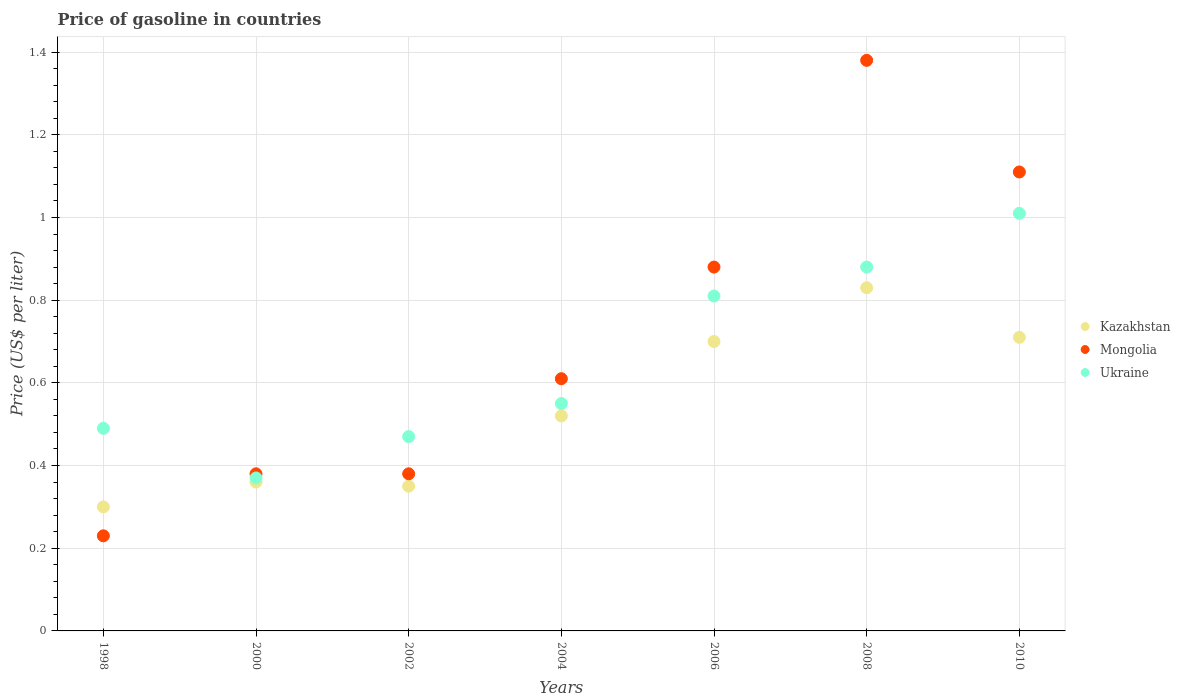What is the price of gasoline in Kazakhstan in 2000?
Give a very brief answer. 0.36. Across all years, what is the maximum price of gasoline in Kazakhstan?
Your response must be concise. 0.83. Across all years, what is the minimum price of gasoline in Ukraine?
Keep it short and to the point. 0.37. What is the total price of gasoline in Kazakhstan in the graph?
Your response must be concise. 3.77. What is the difference between the price of gasoline in Ukraine in 2000 and that in 2006?
Your response must be concise. -0.44. What is the difference between the price of gasoline in Kazakhstan in 2002 and the price of gasoline in Ukraine in 2008?
Make the answer very short. -0.53. What is the average price of gasoline in Kazakhstan per year?
Make the answer very short. 0.54. In the year 2006, what is the difference between the price of gasoline in Ukraine and price of gasoline in Kazakhstan?
Provide a succinct answer. 0.11. In how many years, is the price of gasoline in Ukraine greater than 1.12 US$?
Provide a succinct answer. 0. What is the ratio of the price of gasoline in Mongolia in 1998 to that in 2008?
Keep it short and to the point. 0.17. Is the difference between the price of gasoline in Ukraine in 2006 and 2008 greater than the difference between the price of gasoline in Kazakhstan in 2006 and 2008?
Provide a short and direct response. Yes. What is the difference between the highest and the second highest price of gasoline in Kazakhstan?
Provide a short and direct response. 0.12. What is the difference between the highest and the lowest price of gasoline in Mongolia?
Provide a short and direct response. 1.15. Is the sum of the price of gasoline in Mongolia in 1998 and 2000 greater than the maximum price of gasoline in Kazakhstan across all years?
Your answer should be compact. No. Does the price of gasoline in Ukraine monotonically increase over the years?
Offer a terse response. No. How many dotlines are there?
Offer a very short reply. 3. How many years are there in the graph?
Ensure brevity in your answer.  7. What is the difference between two consecutive major ticks on the Y-axis?
Provide a short and direct response. 0.2. Are the values on the major ticks of Y-axis written in scientific E-notation?
Provide a short and direct response. No. Does the graph contain any zero values?
Keep it short and to the point. No. Does the graph contain grids?
Offer a very short reply. Yes. Where does the legend appear in the graph?
Offer a terse response. Center right. How are the legend labels stacked?
Provide a short and direct response. Vertical. What is the title of the graph?
Your response must be concise. Price of gasoline in countries. What is the label or title of the Y-axis?
Your response must be concise. Price (US$ per liter). What is the Price (US$ per liter) of Mongolia in 1998?
Keep it short and to the point. 0.23. What is the Price (US$ per liter) in Ukraine in 1998?
Offer a terse response. 0.49. What is the Price (US$ per liter) in Kazakhstan in 2000?
Offer a very short reply. 0.36. What is the Price (US$ per liter) in Mongolia in 2000?
Keep it short and to the point. 0.38. What is the Price (US$ per liter) in Ukraine in 2000?
Keep it short and to the point. 0.37. What is the Price (US$ per liter) in Mongolia in 2002?
Your answer should be very brief. 0.38. What is the Price (US$ per liter) in Ukraine in 2002?
Ensure brevity in your answer.  0.47. What is the Price (US$ per liter) in Kazakhstan in 2004?
Provide a short and direct response. 0.52. What is the Price (US$ per liter) of Mongolia in 2004?
Keep it short and to the point. 0.61. What is the Price (US$ per liter) of Ukraine in 2004?
Your answer should be very brief. 0.55. What is the Price (US$ per liter) of Ukraine in 2006?
Provide a succinct answer. 0.81. What is the Price (US$ per liter) in Kazakhstan in 2008?
Make the answer very short. 0.83. What is the Price (US$ per liter) in Mongolia in 2008?
Your answer should be compact. 1.38. What is the Price (US$ per liter) in Ukraine in 2008?
Offer a very short reply. 0.88. What is the Price (US$ per liter) of Kazakhstan in 2010?
Your answer should be compact. 0.71. What is the Price (US$ per liter) of Mongolia in 2010?
Give a very brief answer. 1.11. Across all years, what is the maximum Price (US$ per liter) of Kazakhstan?
Give a very brief answer. 0.83. Across all years, what is the maximum Price (US$ per liter) in Mongolia?
Your answer should be very brief. 1.38. Across all years, what is the maximum Price (US$ per liter) in Ukraine?
Provide a succinct answer. 1.01. Across all years, what is the minimum Price (US$ per liter) in Kazakhstan?
Your answer should be very brief. 0.3. Across all years, what is the minimum Price (US$ per liter) of Mongolia?
Give a very brief answer. 0.23. Across all years, what is the minimum Price (US$ per liter) of Ukraine?
Make the answer very short. 0.37. What is the total Price (US$ per liter) in Kazakhstan in the graph?
Offer a very short reply. 3.77. What is the total Price (US$ per liter) in Mongolia in the graph?
Your response must be concise. 4.97. What is the total Price (US$ per liter) in Ukraine in the graph?
Provide a short and direct response. 4.58. What is the difference between the Price (US$ per liter) of Kazakhstan in 1998 and that in 2000?
Keep it short and to the point. -0.06. What is the difference between the Price (US$ per liter) of Ukraine in 1998 and that in 2000?
Provide a succinct answer. 0.12. What is the difference between the Price (US$ per liter) of Kazakhstan in 1998 and that in 2004?
Offer a very short reply. -0.22. What is the difference between the Price (US$ per liter) of Mongolia in 1998 and that in 2004?
Give a very brief answer. -0.38. What is the difference between the Price (US$ per liter) in Ukraine in 1998 and that in 2004?
Your response must be concise. -0.06. What is the difference between the Price (US$ per liter) of Kazakhstan in 1998 and that in 2006?
Give a very brief answer. -0.4. What is the difference between the Price (US$ per liter) in Mongolia in 1998 and that in 2006?
Make the answer very short. -0.65. What is the difference between the Price (US$ per liter) of Ukraine in 1998 and that in 2006?
Keep it short and to the point. -0.32. What is the difference between the Price (US$ per liter) in Kazakhstan in 1998 and that in 2008?
Make the answer very short. -0.53. What is the difference between the Price (US$ per liter) of Mongolia in 1998 and that in 2008?
Your answer should be compact. -1.15. What is the difference between the Price (US$ per liter) in Ukraine in 1998 and that in 2008?
Make the answer very short. -0.39. What is the difference between the Price (US$ per liter) in Kazakhstan in 1998 and that in 2010?
Offer a terse response. -0.41. What is the difference between the Price (US$ per liter) in Mongolia in 1998 and that in 2010?
Keep it short and to the point. -0.88. What is the difference between the Price (US$ per liter) in Ukraine in 1998 and that in 2010?
Your answer should be compact. -0.52. What is the difference between the Price (US$ per liter) in Kazakhstan in 2000 and that in 2002?
Offer a terse response. 0.01. What is the difference between the Price (US$ per liter) of Ukraine in 2000 and that in 2002?
Your response must be concise. -0.1. What is the difference between the Price (US$ per liter) in Kazakhstan in 2000 and that in 2004?
Offer a terse response. -0.16. What is the difference between the Price (US$ per liter) of Mongolia in 2000 and that in 2004?
Your answer should be very brief. -0.23. What is the difference between the Price (US$ per liter) in Ukraine in 2000 and that in 2004?
Your answer should be very brief. -0.18. What is the difference between the Price (US$ per liter) of Kazakhstan in 2000 and that in 2006?
Offer a terse response. -0.34. What is the difference between the Price (US$ per liter) in Mongolia in 2000 and that in 2006?
Offer a very short reply. -0.5. What is the difference between the Price (US$ per liter) of Ukraine in 2000 and that in 2006?
Your answer should be compact. -0.44. What is the difference between the Price (US$ per liter) of Kazakhstan in 2000 and that in 2008?
Keep it short and to the point. -0.47. What is the difference between the Price (US$ per liter) of Mongolia in 2000 and that in 2008?
Your answer should be very brief. -1. What is the difference between the Price (US$ per liter) of Ukraine in 2000 and that in 2008?
Offer a terse response. -0.51. What is the difference between the Price (US$ per liter) of Kazakhstan in 2000 and that in 2010?
Give a very brief answer. -0.35. What is the difference between the Price (US$ per liter) of Mongolia in 2000 and that in 2010?
Provide a short and direct response. -0.73. What is the difference between the Price (US$ per liter) of Ukraine in 2000 and that in 2010?
Give a very brief answer. -0.64. What is the difference between the Price (US$ per liter) of Kazakhstan in 2002 and that in 2004?
Offer a very short reply. -0.17. What is the difference between the Price (US$ per liter) in Mongolia in 2002 and that in 2004?
Your answer should be compact. -0.23. What is the difference between the Price (US$ per liter) in Ukraine in 2002 and that in 2004?
Offer a terse response. -0.08. What is the difference between the Price (US$ per liter) in Kazakhstan in 2002 and that in 2006?
Make the answer very short. -0.35. What is the difference between the Price (US$ per liter) of Mongolia in 2002 and that in 2006?
Provide a succinct answer. -0.5. What is the difference between the Price (US$ per liter) in Ukraine in 2002 and that in 2006?
Your response must be concise. -0.34. What is the difference between the Price (US$ per liter) in Kazakhstan in 2002 and that in 2008?
Your response must be concise. -0.48. What is the difference between the Price (US$ per liter) in Mongolia in 2002 and that in 2008?
Your answer should be compact. -1. What is the difference between the Price (US$ per liter) in Ukraine in 2002 and that in 2008?
Keep it short and to the point. -0.41. What is the difference between the Price (US$ per liter) in Kazakhstan in 2002 and that in 2010?
Provide a succinct answer. -0.36. What is the difference between the Price (US$ per liter) of Mongolia in 2002 and that in 2010?
Your answer should be compact. -0.73. What is the difference between the Price (US$ per liter) in Ukraine in 2002 and that in 2010?
Offer a very short reply. -0.54. What is the difference between the Price (US$ per liter) of Kazakhstan in 2004 and that in 2006?
Give a very brief answer. -0.18. What is the difference between the Price (US$ per liter) of Mongolia in 2004 and that in 2006?
Provide a succinct answer. -0.27. What is the difference between the Price (US$ per liter) in Ukraine in 2004 and that in 2006?
Keep it short and to the point. -0.26. What is the difference between the Price (US$ per liter) of Kazakhstan in 2004 and that in 2008?
Give a very brief answer. -0.31. What is the difference between the Price (US$ per liter) of Mongolia in 2004 and that in 2008?
Your answer should be compact. -0.77. What is the difference between the Price (US$ per liter) in Ukraine in 2004 and that in 2008?
Offer a terse response. -0.33. What is the difference between the Price (US$ per liter) in Kazakhstan in 2004 and that in 2010?
Your answer should be compact. -0.19. What is the difference between the Price (US$ per liter) of Mongolia in 2004 and that in 2010?
Provide a short and direct response. -0.5. What is the difference between the Price (US$ per liter) in Ukraine in 2004 and that in 2010?
Provide a short and direct response. -0.46. What is the difference between the Price (US$ per liter) of Kazakhstan in 2006 and that in 2008?
Give a very brief answer. -0.13. What is the difference between the Price (US$ per liter) in Mongolia in 2006 and that in 2008?
Your answer should be compact. -0.5. What is the difference between the Price (US$ per liter) in Ukraine in 2006 and that in 2008?
Offer a terse response. -0.07. What is the difference between the Price (US$ per liter) of Kazakhstan in 2006 and that in 2010?
Keep it short and to the point. -0.01. What is the difference between the Price (US$ per liter) of Mongolia in 2006 and that in 2010?
Provide a succinct answer. -0.23. What is the difference between the Price (US$ per liter) of Ukraine in 2006 and that in 2010?
Keep it short and to the point. -0.2. What is the difference between the Price (US$ per liter) of Kazakhstan in 2008 and that in 2010?
Your answer should be compact. 0.12. What is the difference between the Price (US$ per liter) of Mongolia in 2008 and that in 2010?
Your answer should be compact. 0.27. What is the difference between the Price (US$ per liter) of Ukraine in 2008 and that in 2010?
Make the answer very short. -0.13. What is the difference between the Price (US$ per liter) in Kazakhstan in 1998 and the Price (US$ per liter) in Mongolia in 2000?
Your answer should be compact. -0.08. What is the difference between the Price (US$ per liter) of Kazakhstan in 1998 and the Price (US$ per liter) of Ukraine in 2000?
Offer a terse response. -0.07. What is the difference between the Price (US$ per liter) in Mongolia in 1998 and the Price (US$ per liter) in Ukraine in 2000?
Offer a terse response. -0.14. What is the difference between the Price (US$ per liter) in Kazakhstan in 1998 and the Price (US$ per liter) in Mongolia in 2002?
Give a very brief answer. -0.08. What is the difference between the Price (US$ per liter) of Kazakhstan in 1998 and the Price (US$ per liter) of Ukraine in 2002?
Ensure brevity in your answer.  -0.17. What is the difference between the Price (US$ per liter) in Mongolia in 1998 and the Price (US$ per liter) in Ukraine in 2002?
Provide a short and direct response. -0.24. What is the difference between the Price (US$ per liter) in Kazakhstan in 1998 and the Price (US$ per liter) in Mongolia in 2004?
Keep it short and to the point. -0.31. What is the difference between the Price (US$ per liter) of Kazakhstan in 1998 and the Price (US$ per liter) of Ukraine in 2004?
Make the answer very short. -0.25. What is the difference between the Price (US$ per liter) of Mongolia in 1998 and the Price (US$ per liter) of Ukraine in 2004?
Make the answer very short. -0.32. What is the difference between the Price (US$ per liter) of Kazakhstan in 1998 and the Price (US$ per liter) of Mongolia in 2006?
Your answer should be compact. -0.58. What is the difference between the Price (US$ per liter) in Kazakhstan in 1998 and the Price (US$ per liter) in Ukraine in 2006?
Give a very brief answer. -0.51. What is the difference between the Price (US$ per liter) of Mongolia in 1998 and the Price (US$ per liter) of Ukraine in 2006?
Your answer should be compact. -0.58. What is the difference between the Price (US$ per liter) in Kazakhstan in 1998 and the Price (US$ per liter) in Mongolia in 2008?
Offer a terse response. -1.08. What is the difference between the Price (US$ per liter) of Kazakhstan in 1998 and the Price (US$ per liter) of Ukraine in 2008?
Provide a succinct answer. -0.58. What is the difference between the Price (US$ per liter) in Mongolia in 1998 and the Price (US$ per liter) in Ukraine in 2008?
Provide a short and direct response. -0.65. What is the difference between the Price (US$ per liter) in Kazakhstan in 1998 and the Price (US$ per liter) in Mongolia in 2010?
Make the answer very short. -0.81. What is the difference between the Price (US$ per liter) of Kazakhstan in 1998 and the Price (US$ per liter) of Ukraine in 2010?
Provide a succinct answer. -0.71. What is the difference between the Price (US$ per liter) of Mongolia in 1998 and the Price (US$ per liter) of Ukraine in 2010?
Offer a terse response. -0.78. What is the difference between the Price (US$ per liter) of Kazakhstan in 2000 and the Price (US$ per liter) of Mongolia in 2002?
Ensure brevity in your answer.  -0.02. What is the difference between the Price (US$ per liter) of Kazakhstan in 2000 and the Price (US$ per liter) of Ukraine in 2002?
Provide a short and direct response. -0.11. What is the difference between the Price (US$ per liter) of Mongolia in 2000 and the Price (US$ per liter) of Ukraine in 2002?
Offer a terse response. -0.09. What is the difference between the Price (US$ per liter) of Kazakhstan in 2000 and the Price (US$ per liter) of Mongolia in 2004?
Make the answer very short. -0.25. What is the difference between the Price (US$ per liter) of Kazakhstan in 2000 and the Price (US$ per liter) of Ukraine in 2004?
Keep it short and to the point. -0.19. What is the difference between the Price (US$ per liter) of Mongolia in 2000 and the Price (US$ per liter) of Ukraine in 2004?
Offer a very short reply. -0.17. What is the difference between the Price (US$ per liter) of Kazakhstan in 2000 and the Price (US$ per liter) of Mongolia in 2006?
Offer a very short reply. -0.52. What is the difference between the Price (US$ per liter) in Kazakhstan in 2000 and the Price (US$ per liter) in Ukraine in 2006?
Offer a very short reply. -0.45. What is the difference between the Price (US$ per liter) of Mongolia in 2000 and the Price (US$ per liter) of Ukraine in 2006?
Offer a terse response. -0.43. What is the difference between the Price (US$ per liter) of Kazakhstan in 2000 and the Price (US$ per liter) of Mongolia in 2008?
Keep it short and to the point. -1.02. What is the difference between the Price (US$ per liter) in Kazakhstan in 2000 and the Price (US$ per liter) in Ukraine in 2008?
Give a very brief answer. -0.52. What is the difference between the Price (US$ per liter) in Mongolia in 2000 and the Price (US$ per liter) in Ukraine in 2008?
Your answer should be very brief. -0.5. What is the difference between the Price (US$ per liter) in Kazakhstan in 2000 and the Price (US$ per liter) in Mongolia in 2010?
Offer a very short reply. -0.75. What is the difference between the Price (US$ per liter) of Kazakhstan in 2000 and the Price (US$ per liter) of Ukraine in 2010?
Keep it short and to the point. -0.65. What is the difference between the Price (US$ per liter) of Mongolia in 2000 and the Price (US$ per liter) of Ukraine in 2010?
Offer a very short reply. -0.63. What is the difference between the Price (US$ per liter) of Kazakhstan in 2002 and the Price (US$ per liter) of Mongolia in 2004?
Give a very brief answer. -0.26. What is the difference between the Price (US$ per liter) in Mongolia in 2002 and the Price (US$ per liter) in Ukraine in 2004?
Offer a terse response. -0.17. What is the difference between the Price (US$ per liter) in Kazakhstan in 2002 and the Price (US$ per liter) in Mongolia in 2006?
Ensure brevity in your answer.  -0.53. What is the difference between the Price (US$ per liter) of Kazakhstan in 2002 and the Price (US$ per liter) of Ukraine in 2006?
Offer a terse response. -0.46. What is the difference between the Price (US$ per liter) in Mongolia in 2002 and the Price (US$ per liter) in Ukraine in 2006?
Your answer should be very brief. -0.43. What is the difference between the Price (US$ per liter) in Kazakhstan in 2002 and the Price (US$ per liter) in Mongolia in 2008?
Offer a terse response. -1.03. What is the difference between the Price (US$ per liter) in Kazakhstan in 2002 and the Price (US$ per liter) in Ukraine in 2008?
Offer a very short reply. -0.53. What is the difference between the Price (US$ per liter) in Kazakhstan in 2002 and the Price (US$ per liter) in Mongolia in 2010?
Offer a very short reply. -0.76. What is the difference between the Price (US$ per liter) of Kazakhstan in 2002 and the Price (US$ per liter) of Ukraine in 2010?
Offer a terse response. -0.66. What is the difference between the Price (US$ per liter) in Mongolia in 2002 and the Price (US$ per liter) in Ukraine in 2010?
Offer a terse response. -0.63. What is the difference between the Price (US$ per liter) in Kazakhstan in 2004 and the Price (US$ per liter) in Mongolia in 2006?
Your answer should be very brief. -0.36. What is the difference between the Price (US$ per liter) of Kazakhstan in 2004 and the Price (US$ per liter) of Ukraine in 2006?
Provide a short and direct response. -0.29. What is the difference between the Price (US$ per liter) in Mongolia in 2004 and the Price (US$ per liter) in Ukraine in 2006?
Offer a very short reply. -0.2. What is the difference between the Price (US$ per liter) in Kazakhstan in 2004 and the Price (US$ per liter) in Mongolia in 2008?
Offer a very short reply. -0.86. What is the difference between the Price (US$ per liter) of Kazakhstan in 2004 and the Price (US$ per liter) of Ukraine in 2008?
Your answer should be very brief. -0.36. What is the difference between the Price (US$ per liter) of Mongolia in 2004 and the Price (US$ per liter) of Ukraine in 2008?
Your response must be concise. -0.27. What is the difference between the Price (US$ per liter) of Kazakhstan in 2004 and the Price (US$ per liter) of Mongolia in 2010?
Offer a terse response. -0.59. What is the difference between the Price (US$ per liter) in Kazakhstan in 2004 and the Price (US$ per liter) in Ukraine in 2010?
Give a very brief answer. -0.49. What is the difference between the Price (US$ per liter) of Kazakhstan in 2006 and the Price (US$ per liter) of Mongolia in 2008?
Make the answer very short. -0.68. What is the difference between the Price (US$ per liter) in Kazakhstan in 2006 and the Price (US$ per liter) in Ukraine in 2008?
Your answer should be compact. -0.18. What is the difference between the Price (US$ per liter) in Mongolia in 2006 and the Price (US$ per liter) in Ukraine in 2008?
Your answer should be compact. 0. What is the difference between the Price (US$ per liter) of Kazakhstan in 2006 and the Price (US$ per liter) of Mongolia in 2010?
Your answer should be compact. -0.41. What is the difference between the Price (US$ per liter) of Kazakhstan in 2006 and the Price (US$ per liter) of Ukraine in 2010?
Offer a terse response. -0.31. What is the difference between the Price (US$ per liter) in Mongolia in 2006 and the Price (US$ per liter) in Ukraine in 2010?
Give a very brief answer. -0.13. What is the difference between the Price (US$ per liter) in Kazakhstan in 2008 and the Price (US$ per liter) in Mongolia in 2010?
Your answer should be very brief. -0.28. What is the difference between the Price (US$ per liter) of Kazakhstan in 2008 and the Price (US$ per liter) of Ukraine in 2010?
Provide a short and direct response. -0.18. What is the difference between the Price (US$ per liter) in Mongolia in 2008 and the Price (US$ per liter) in Ukraine in 2010?
Give a very brief answer. 0.37. What is the average Price (US$ per liter) of Kazakhstan per year?
Offer a very short reply. 0.54. What is the average Price (US$ per liter) of Mongolia per year?
Make the answer very short. 0.71. What is the average Price (US$ per liter) of Ukraine per year?
Provide a succinct answer. 0.65. In the year 1998, what is the difference between the Price (US$ per liter) in Kazakhstan and Price (US$ per liter) in Mongolia?
Your answer should be compact. 0.07. In the year 1998, what is the difference between the Price (US$ per liter) in Kazakhstan and Price (US$ per liter) in Ukraine?
Offer a terse response. -0.19. In the year 1998, what is the difference between the Price (US$ per liter) in Mongolia and Price (US$ per liter) in Ukraine?
Provide a succinct answer. -0.26. In the year 2000, what is the difference between the Price (US$ per liter) in Kazakhstan and Price (US$ per liter) in Mongolia?
Ensure brevity in your answer.  -0.02. In the year 2000, what is the difference between the Price (US$ per liter) of Kazakhstan and Price (US$ per liter) of Ukraine?
Keep it short and to the point. -0.01. In the year 2002, what is the difference between the Price (US$ per liter) of Kazakhstan and Price (US$ per liter) of Mongolia?
Ensure brevity in your answer.  -0.03. In the year 2002, what is the difference between the Price (US$ per liter) of Kazakhstan and Price (US$ per liter) of Ukraine?
Make the answer very short. -0.12. In the year 2002, what is the difference between the Price (US$ per liter) of Mongolia and Price (US$ per liter) of Ukraine?
Your answer should be compact. -0.09. In the year 2004, what is the difference between the Price (US$ per liter) in Kazakhstan and Price (US$ per liter) in Mongolia?
Keep it short and to the point. -0.09. In the year 2004, what is the difference between the Price (US$ per liter) of Kazakhstan and Price (US$ per liter) of Ukraine?
Make the answer very short. -0.03. In the year 2004, what is the difference between the Price (US$ per liter) in Mongolia and Price (US$ per liter) in Ukraine?
Offer a very short reply. 0.06. In the year 2006, what is the difference between the Price (US$ per liter) of Kazakhstan and Price (US$ per liter) of Mongolia?
Make the answer very short. -0.18. In the year 2006, what is the difference between the Price (US$ per liter) of Kazakhstan and Price (US$ per liter) of Ukraine?
Provide a short and direct response. -0.11. In the year 2006, what is the difference between the Price (US$ per liter) in Mongolia and Price (US$ per liter) in Ukraine?
Your answer should be very brief. 0.07. In the year 2008, what is the difference between the Price (US$ per liter) in Kazakhstan and Price (US$ per liter) in Mongolia?
Provide a short and direct response. -0.55. In the year 2010, what is the difference between the Price (US$ per liter) of Kazakhstan and Price (US$ per liter) of Mongolia?
Give a very brief answer. -0.4. In the year 2010, what is the difference between the Price (US$ per liter) in Kazakhstan and Price (US$ per liter) in Ukraine?
Your response must be concise. -0.3. What is the ratio of the Price (US$ per liter) in Kazakhstan in 1998 to that in 2000?
Keep it short and to the point. 0.83. What is the ratio of the Price (US$ per liter) in Mongolia in 1998 to that in 2000?
Make the answer very short. 0.61. What is the ratio of the Price (US$ per liter) of Ukraine in 1998 to that in 2000?
Keep it short and to the point. 1.32. What is the ratio of the Price (US$ per liter) in Kazakhstan in 1998 to that in 2002?
Your response must be concise. 0.86. What is the ratio of the Price (US$ per liter) in Mongolia in 1998 to that in 2002?
Offer a very short reply. 0.61. What is the ratio of the Price (US$ per liter) of Ukraine in 1998 to that in 2002?
Provide a short and direct response. 1.04. What is the ratio of the Price (US$ per liter) of Kazakhstan in 1998 to that in 2004?
Provide a succinct answer. 0.58. What is the ratio of the Price (US$ per liter) in Mongolia in 1998 to that in 2004?
Provide a succinct answer. 0.38. What is the ratio of the Price (US$ per liter) of Ukraine in 1998 to that in 2004?
Make the answer very short. 0.89. What is the ratio of the Price (US$ per liter) of Kazakhstan in 1998 to that in 2006?
Make the answer very short. 0.43. What is the ratio of the Price (US$ per liter) in Mongolia in 1998 to that in 2006?
Your answer should be compact. 0.26. What is the ratio of the Price (US$ per liter) in Ukraine in 1998 to that in 2006?
Your answer should be compact. 0.6. What is the ratio of the Price (US$ per liter) of Kazakhstan in 1998 to that in 2008?
Your answer should be very brief. 0.36. What is the ratio of the Price (US$ per liter) of Ukraine in 1998 to that in 2008?
Your response must be concise. 0.56. What is the ratio of the Price (US$ per liter) of Kazakhstan in 1998 to that in 2010?
Your answer should be very brief. 0.42. What is the ratio of the Price (US$ per liter) of Mongolia in 1998 to that in 2010?
Ensure brevity in your answer.  0.21. What is the ratio of the Price (US$ per liter) of Ukraine in 1998 to that in 2010?
Keep it short and to the point. 0.49. What is the ratio of the Price (US$ per liter) in Kazakhstan in 2000 to that in 2002?
Keep it short and to the point. 1.03. What is the ratio of the Price (US$ per liter) of Mongolia in 2000 to that in 2002?
Offer a terse response. 1. What is the ratio of the Price (US$ per liter) in Ukraine in 2000 to that in 2002?
Make the answer very short. 0.79. What is the ratio of the Price (US$ per liter) in Kazakhstan in 2000 to that in 2004?
Provide a short and direct response. 0.69. What is the ratio of the Price (US$ per liter) of Mongolia in 2000 to that in 2004?
Your answer should be compact. 0.62. What is the ratio of the Price (US$ per liter) in Ukraine in 2000 to that in 2004?
Provide a succinct answer. 0.67. What is the ratio of the Price (US$ per liter) of Kazakhstan in 2000 to that in 2006?
Offer a terse response. 0.51. What is the ratio of the Price (US$ per liter) of Mongolia in 2000 to that in 2006?
Your answer should be very brief. 0.43. What is the ratio of the Price (US$ per liter) in Ukraine in 2000 to that in 2006?
Keep it short and to the point. 0.46. What is the ratio of the Price (US$ per liter) in Kazakhstan in 2000 to that in 2008?
Your answer should be very brief. 0.43. What is the ratio of the Price (US$ per liter) in Mongolia in 2000 to that in 2008?
Provide a succinct answer. 0.28. What is the ratio of the Price (US$ per liter) in Ukraine in 2000 to that in 2008?
Your answer should be very brief. 0.42. What is the ratio of the Price (US$ per liter) in Kazakhstan in 2000 to that in 2010?
Your response must be concise. 0.51. What is the ratio of the Price (US$ per liter) of Mongolia in 2000 to that in 2010?
Keep it short and to the point. 0.34. What is the ratio of the Price (US$ per liter) of Ukraine in 2000 to that in 2010?
Your response must be concise. 0.37. What is the ratio of the Price (US$ per liter) in Kazakhstan in 2002 to that in 2004?
Keep it short and to the point. 0.67. What is the ratio of the Price (US$ per liter) of Mongolia in 2002 to that in 2004?
Keep it short and to the point. 0.62. What is the ratio of the Price (US$ per liter) in Ukraine in 2002 to that in 2004?
Ensure brevity in your answer.  0.85. What is the ratio of the Price (US$ per liter) in Mongolia in 2002 to that in 2006?
Your response must be concise. 0.43. What is the ratio of the Price (US$ per liter) in Ukraine in 2002 to that in 2006?
Provide a short and direct response. 0.58. What is the ratio of the Price (US$ per liter) of Kazakhstan in 2002 to that in 2008?
Give a very brief answer. 0.42. What is the ratio of the Price (US$ per liter) of Mongolia in 2002 to that in 2008?
Provide a short and direct response. 0.28. What is the ratio of the Price (US$ per liter) in Ukraine in 2002 to that in 2008?
Your response must be concise. 0.53. What is the ratio of the Price (US$ per liter) of Kazakhstan in 2002 to that in 2010?
Provide a short and direct response. 0.49. What is the ratio of the Price (US$ per liter) of Mongolia in 2002 to that in 2010?
Give a very brief answer. 0.34. What is the ratio of the Price (US$ per liter) in Ukraine in 2002 to that in 2010?
Offer a very short reply. 0.47. What is the ratio of the Price (US$ per liter) of Kazakhstan in 2004 to that in 2006?
Your answer should be compact. 0.74. What is the ratio of the Price (US$ per liter) in Mongolia in 2004 to that in 2006?
Your answer should be compact. 0.69. What is the ratio of the Price (US$ per liter) of Ukraine in 2004 to that in 2006?
Provide a succinct answer. 0.68. What is the ratio of the Price (US$ per liter) of Kazakhstan in 2004 to that in 2008?
Ensure brevity in your answer.  0.63. What is the ratio of the Price (US$ per liter) of Mongolia in 2004 to that in 2008?
Ensure brevity in your answer.  0.44. What is the ratio of the Price (US$ per liter) of Ukraine in 2004 to that in 2008?
Make the answer very short. 0.62. What is the ratio of the Price (US$ per liter) of Kazakhstan in 2004 to that in 2010?
Provide a short and direct response. 0.73. What is the ratio of the Price (US$ per liter) in Mongolia in 2004 to that in 2010?
Keep it short and to the point. 0.55. What is the ratio of the Price (US$ per liter) in Ukraine in 2004 to that in 2010?
Your answer should be very brief. 0.54. What is the ratio of the Price (US$ per liter) in Kazakhstan in 2006 to that in 2008?
Offer a very short reply. 0.84. What is the ratio of the Price (US$ per liter) in Mongolia in 2006 to that in 2008?
Make the answer very short. 0.64. What is the ratio of the Price (US$ per liter) in Ukraine in 2006 to that in 2008?
Offer a terse response. 0.92. What is the ratio of the Price (US$ per liter) of Kazakhstan in 2006 to that in 2010?
Keep it short and to the point. 0.99. What is the ratio of the Price (US$ per liter) of Mongolia in 2006 to that in 2010?
Your answer should be very brief. 0.79. What is the ratio of the Price (US$ per liter) of Ukraine in 2006 to that in 2010?
Your answer should be very brief. 0.8. What is the ratio of the Price (US$ per liter) in Kazakhstan in 2008 to that in 2010?
Keep it short and to the point. 1.17. What is the ratio of the Price (US$ per liter) in Mongolia in 2008 to that in 2010?
Make the answer very short. 1.24. What is the ratio of the Price (US$ per liter) of Ukraine in 2008 to that in 2010?
Your response must be concise. 0.87. What is the difference between the highest and the second highest Price (US$ per liter) of Kazakhstan?
Make the answer very short. 0.12. What is the difference between the highest and the second highest Price (US$ per liter) in Mongolia?
Your answer should be compact. 0.27. What is the difference between the highest and the second highest Price (US$ per liter) in Ukraine?
Make the answer very short. 0.13. What is the difference between the highest and the lowest Price (US$ per liter) of Kazakhstan?
Make the answer very short. 0.53. What is the difference between the highest and the lowest Price (US$ per liter) in Mongolia?
Offer a terse response. 1.15. What is the difference between the highest and the lowest Price (US$ per liter) in Ukraine?
Your response must be concise. 0.64. 